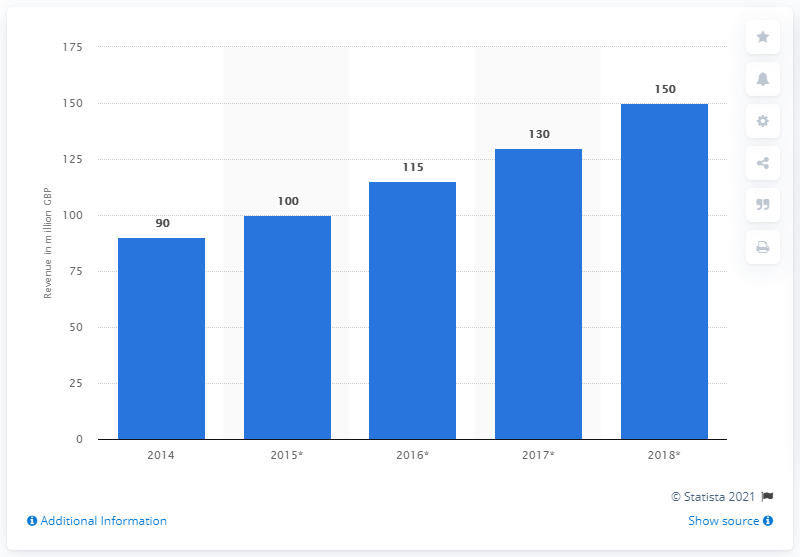Outline some significant characteristics in this image. In 2017, the estimated annual revenue generated from the telehealth market in the UK was approximately 130 million. 